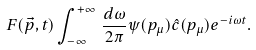<formula> <loc_0><loc_0><loc_500><loc_500>F ( \vec { p } , t ) \int ^ { + \infty } _ { - \infty } \, \frac { d \omega } { 2 \pi } \psi ( p _ { \mu } ) \hat { c } ( p _ { \mu } ) e ^ { - i \omega t } .</formula> 